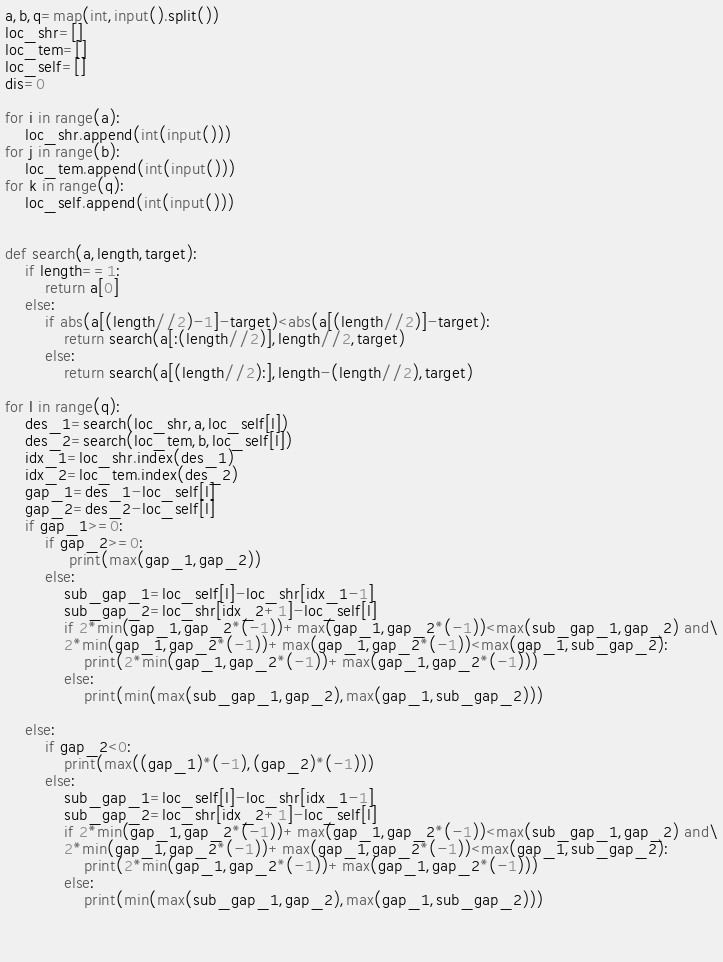<code> <loc_0><loc_0><loc_500><loc_500><_Python_>a,b,q=map(int,input().split())
loc_shr=[]
loc_tem=[]
loc_self=[]
dis=0

for i in range(a):
    loc_shr.append(int(input()))
for j in range(b):
    loc_tem.append(int(input()))
for k in range(q):
    loc_self.append(int(input()))
    

def search(a,length,target):
    if length==1:
        return a[0]
    else:
        if abs(a[(length//2)-1]-target)<abs(a[(length//2)]-target):
            return search(a[:(length//2)],length//2,target)
        else:
            return search(a[(length//2):],length-(length//2),target)
        
for l in range(q):
    des_1=search(loc_shr,a,loc_self[l])
    des_2=search(loc_tem,b,loc_self[l])
    idx_1=loc_shr.index(des_1)
    idx_2=loc_tem.index(des_2)
    gap_1=des_1-loc_self[l]
    gap_2=des_2-loc_self[l]
    if gap_1>=0:
        if gap_2>=0:
             print(max(gap_1,gap_2))
        else:
            sub_gap_1=loc_self[l]-loc_shr[idx_1-1]
            sub_gap_2=loc_shr[idx_2+1]-loc_self[l]
            if 2*min(gap_1,gap_2*(-1))+max(gap_1,gap_2*(-1))<max(sub_gap_1,gap_2) and\
            2*min(gap_1,gap_2*(-1))+max(gap_1,gap_2*(-1))<max(gap_1,sub_gap_2):
                print(2*min(gap_1,gap_2*(-1))+max(gap_1,gap_2*(-1)))
            else:
                print(min(max(sub_gap_1,gap_2),max(gap_1,sub_gap_2)))
            
    else:
        if gap_2<0:
            print(max((gap_1)*(-1),(gap_2)*(-1)))
        else:
            sub_gap_1=loc_self[l]-loc_shr[idx_1-1]
            sub_gap_2=loc_shr[idx_2+1]-loc_self[l]
            if 2*min(gap_1,gap_2*(-1))+max(gap_1,gap_2*(-1))<max(sub_gap_1,gap_2) and\
            2*min(gap_1,gap_2*(-1))+max(gap_1,gap_2*(-1))<max(gap_1,sub_gap_2):
                print(2*min(gap_1,gap_2*(-1))+max(gap_1,gap_2*(-1)))
            else:
                print(min(max(sub_gap_1,gap_2),max(gap_1,sub_gap_2)))
        

                   </code> 